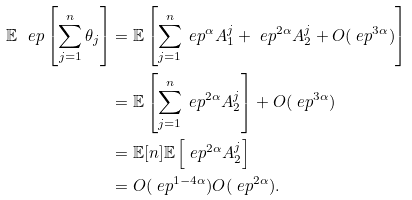<formula> <loc_0><loc_0><loc_500><loc_500>\mathbb { E } ^ { \ } e p \left [ \sum _ { j = 1 } ^ { n } \theta _ { j } \right ] & = \mathbb { E } \left [ \sum _ { j = 1 } ^ { n } \ e p ^ { \alpha } A ^ { j } _ { 1 } + \ e p ^ { 2 \alpha } A ^ { j } _ { 2 } + O ( \ e p ^ { 3 \alpha } ) \right ] \\ & = \mathbb { E } \left [ \sum _ { j = 1 } ^ { n } \ e p ^ { 2 \alpha } A ^ { j } _ { 2 } \right ] + O ( \ e p ^ { 3 \alpha } ) \\ & = \mathbb { E } [ n ] \mathbb { E } \left [ \ e p ^ { 2 \alpha } A ^ { j } _ { 2 } \right ] \\ & = O ( \ e p ^ { 1 - 4 \alpha } ) O ( \ e p ^ { 2 \alpha } ) .</formula> 